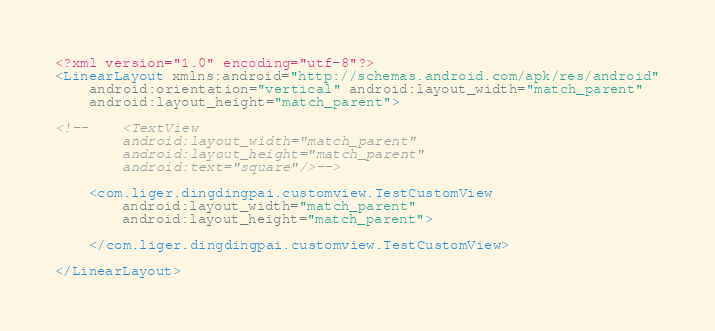<code> <loc_0><loc_0><loc_500><loc_500><_XML_><?xml version="1.0" encoding="utf-8"?>
<LinearLayout xmlns:android="http://schemas.android.com/apk/res/android"
    android:orientation="vertical" android:layout_width="match_parent"
    android:layout_height="match_parent">

<!--    <TextView
        android:layout_width="match_parent"
        android:layout_height="match_parent"
        android:text="square"/>-->

    <com.liger.dingdingpai.customview.TestCustomView
        android:layout_width="match_parent"
        android:layout_height="match_parent">

    </com.liger.dingdingpai.customview.TestCustomView>

</LinearLayout></code> 